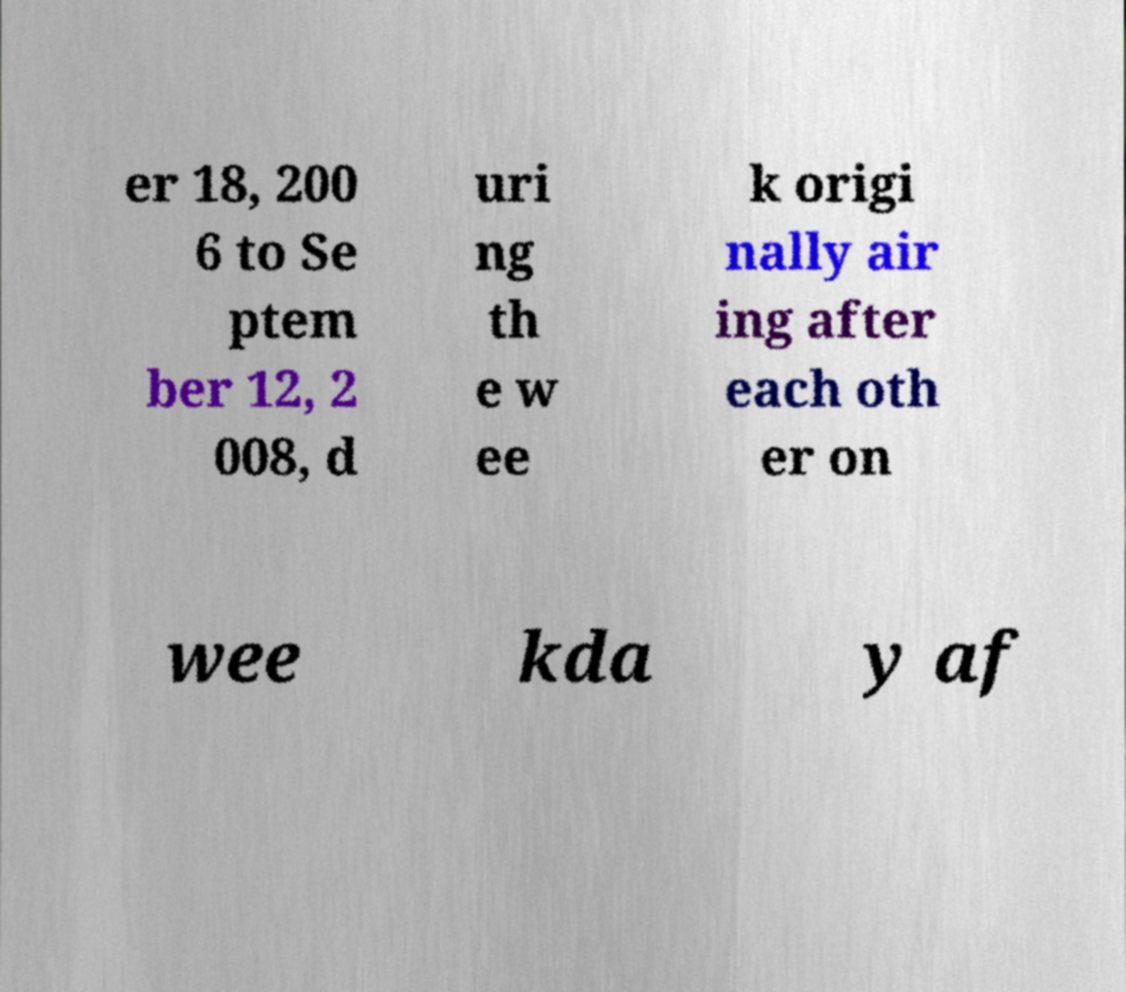What messages or text are displayed in this image? I need them in a readable, typed format. er 18, 200 6 to Se ptem ber 12, 2 008, d uri ng th e w ee k origi nally air ing after each oth er on wee kda y af 